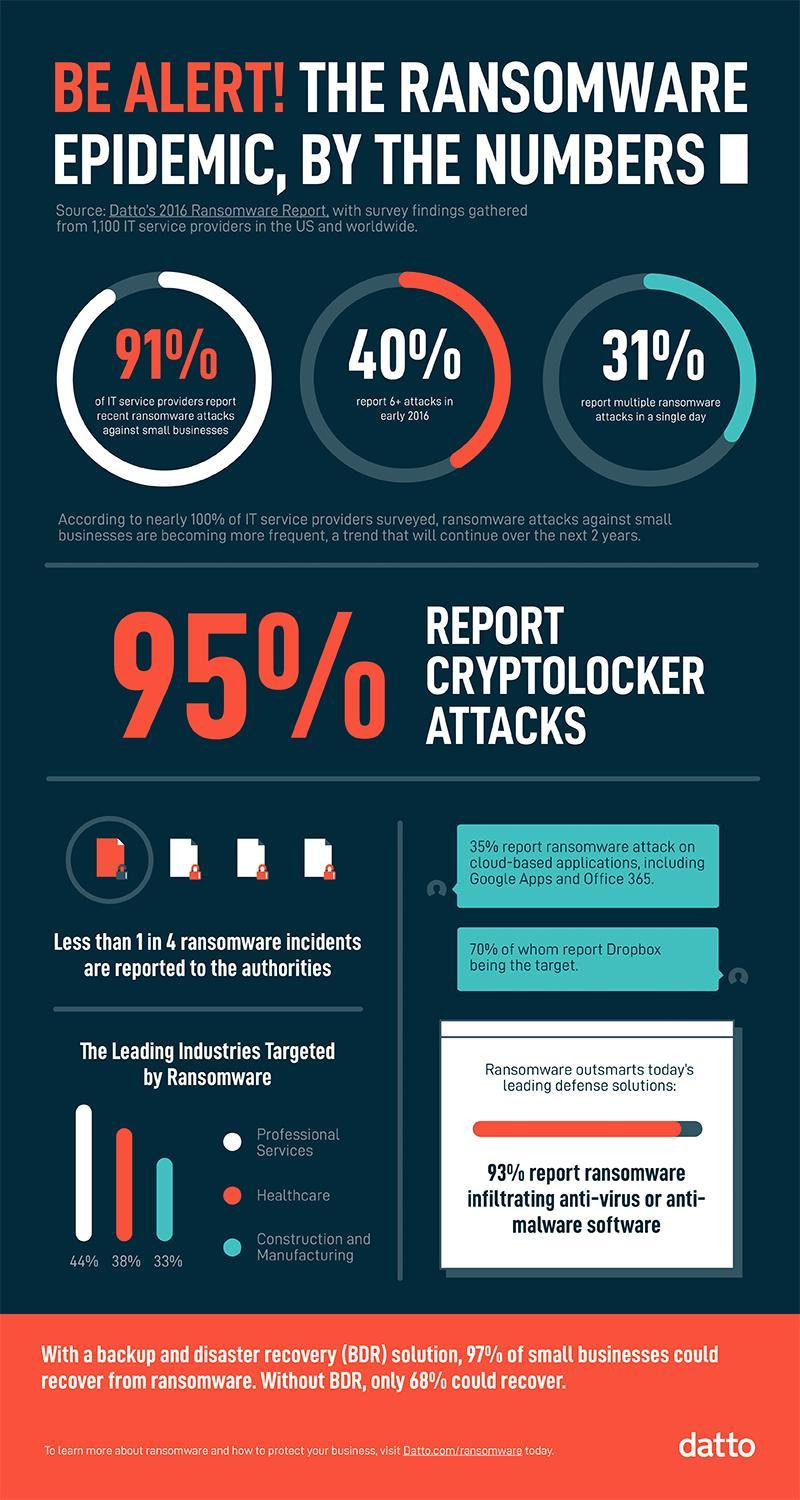What percentage of Healthcare, Construction, and Manufacturing are targeted by Ransomeware, taken together?
Answer the question with a short phrase. 71% What percentage of professional services and Healthcare are targeted by Ransomeware, taken together? 82% What percentage didn't report a cyberlocker attack? 5% What percentage report ransomware attacks against small businesses? 91% What percentage of professional services are targeted by Ransomeware? 44% What percentage report multiple ransomware attacks in a single day? 31% 